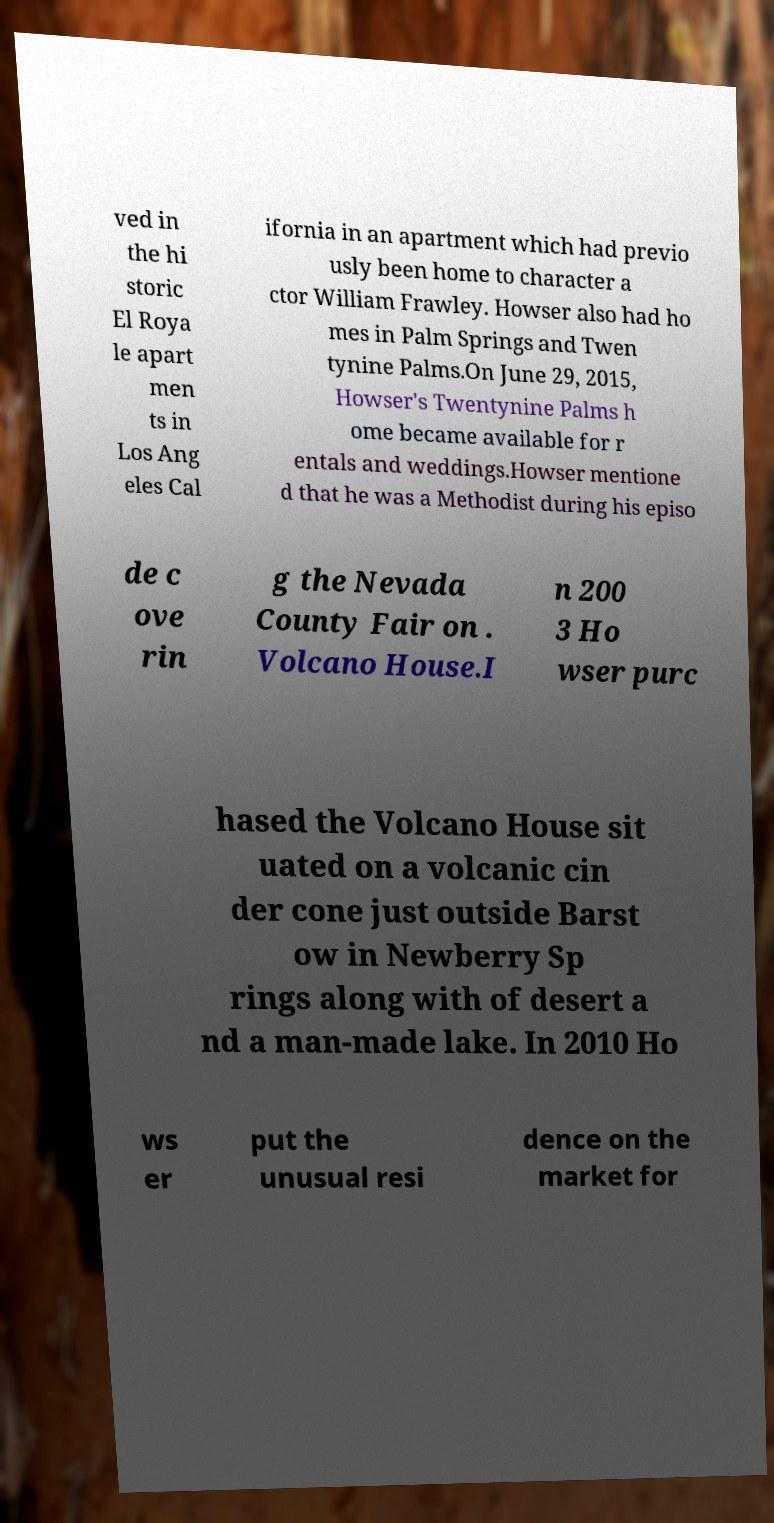There's text embedded in this image that I need extracted. Can you transcribe it verbatim? ved in the hi storic El Roya le apart men ts in Los Ang eles Cal ifornia in an apartment which had previo usly been home to character a ctor William Frawley. Howser also had ho mes in Palm Springs and Twen tynine Palms.On June 29, 2015, Howser's Twentynine Palms h ome became available for r entals and weddings.Howser mentione d that he was a Methodist during his episo de c ove rin g the Nevada County Fair on . Volcano House.I n 200 3 Ho wser purc hased the Volcano House sit uated on a volcanic cin der cone just outside Barst ow in Newberry Sp rings along with of desert a nd a man-made lake. In 2010 Ho ws er put the unusual resi dence on the market for 